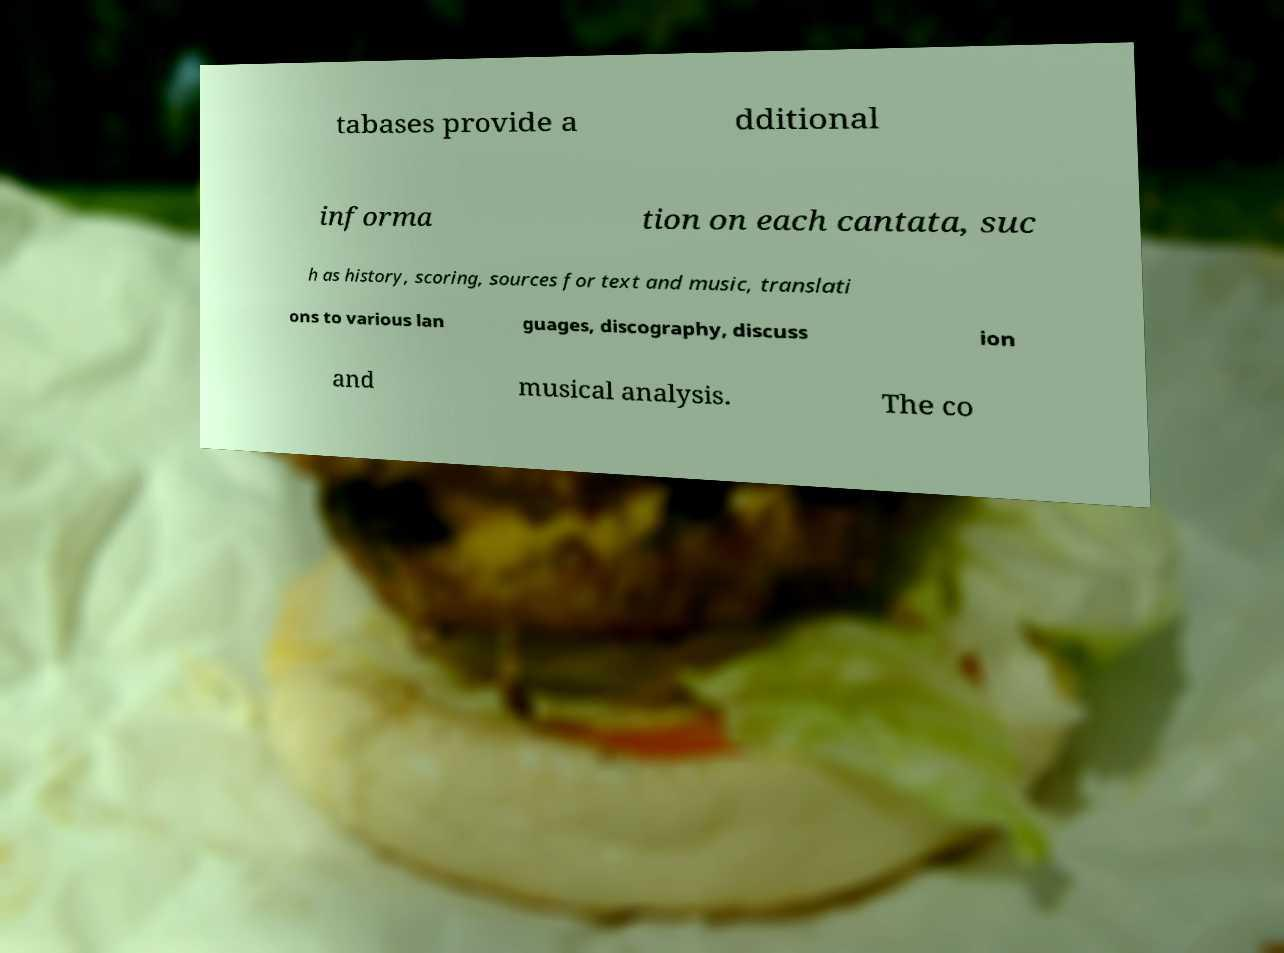Could you assist in decoding the text presented in this image and type it out clearly? tabases provide a dditional informa tion on each cantata, suc h as history, scoring, sources for text and music, translati ons to various lan guages, discography, discuss ion and musical analysis. The co 